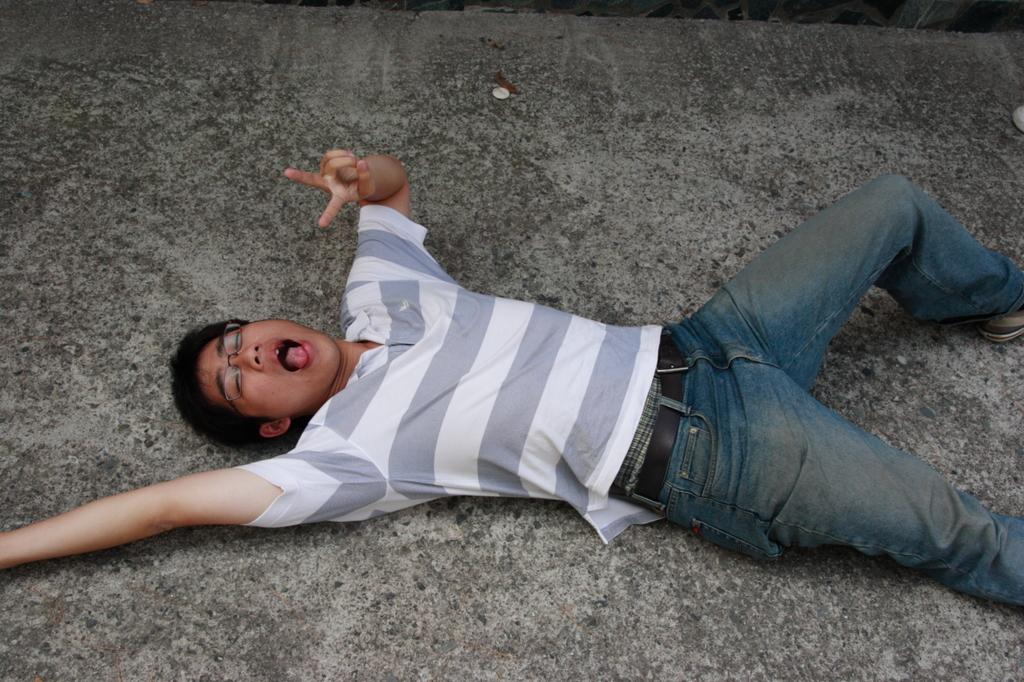What is the position of the person in the image? There is a person lying on the ground in the image. What object is also present on the ground in the image? There is a coin on the ground in the image. What rhythm is the bat playing in the image? There is no bat or any musical instrument present in the image. 